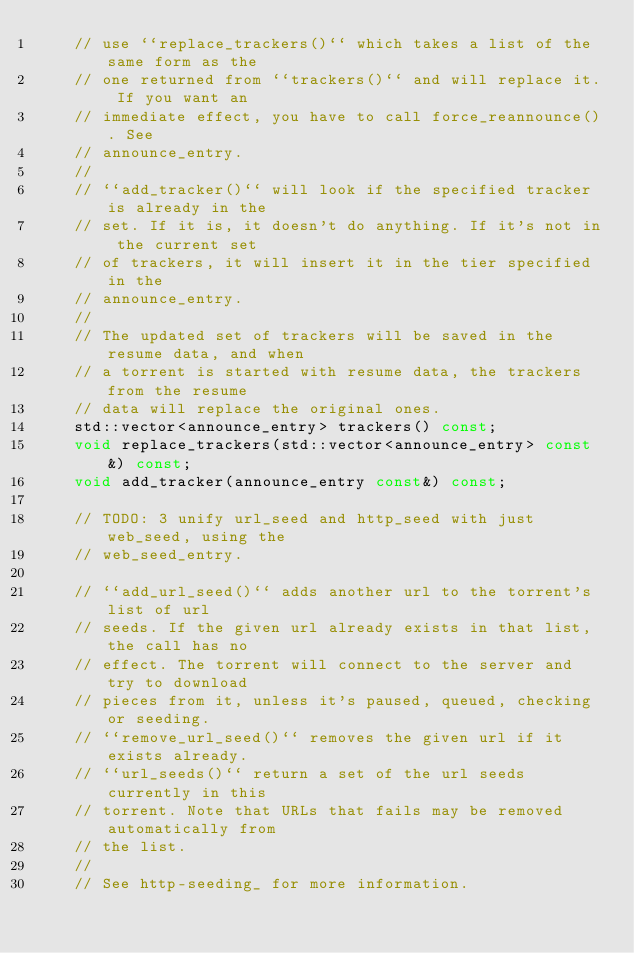<code> <loc_0><loc_0><loc_500><loc_500><_C++_>		// use ``replace_trackers()`` which takes a list of the same form as the
		// one returned from ``trackers()`` and will replace it. If you want an
		// immediate effect, you have to call force_reannounce(). See
		// announce_entry.
		//
		// ``add_tracker()`` will look if the specified tracker is already in the
		// set. If it is, it doesn't do anything. If it's not in the current set
		// of trackers, it will insert it in the tier specified in the
		// announce_entry.
		//
		// The updated set of trackers will be saved in the resume data, and when
		// a torrent is started with resume data, the trackers from the resume
		// data will replace the original ones.
		std::vector<announce_entry> trackers() const;
		void replace_trackers(std::vector<announce_entry> const&) const;
		void add_tracker(announce_entry const&) const;

		// TODO: 3 unify url_seed and http_seed with just web_seed, using the
		// web_seed_entry.

		// ``add_url_seed()`` adds another url to the torrent's list of url
		// seeds. If the given url already exists in that list, the call has no
		// effect. The torrent will connect to the server and try to download
		// pieces from it, unless it's paused, queued, checking or seeding.
		// ``remove_url_seed()`` removes the given url if it exists already.
		// ``url_seeds()`` return a set of the url seeds currently in this
		// torrent. Note that URLs that fails may be removed automatically from
		// the list.
		//
		// See http-seeding_ for more information.</code> 